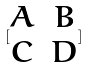Convert formula to latex. <formula><loc_0><loc_0><loc_500><loc_500>[ \begin{matrix} A & B \\ C & D \end{matrix} ]</formula> 